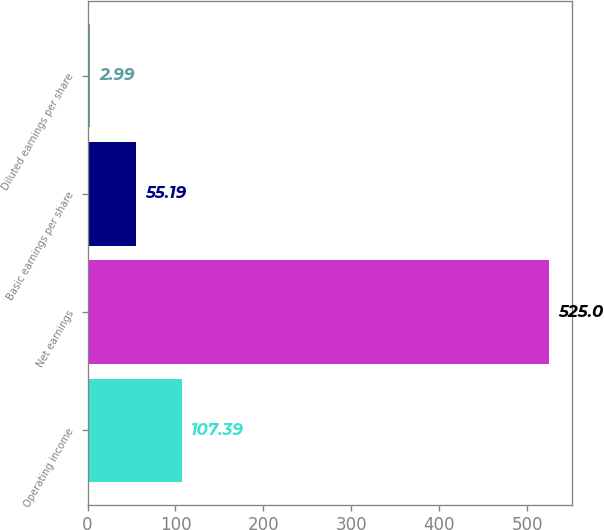<chart> <loc_0><loc_0><loc_500><loc_500><bar_chart><fcel>Operating income<fcel>Net earnings<fcel>Basic earnings per share<fcel>Diluted earnings per share<nl><fcel>107.39<fcel>525<fcel>55.19<fcel>2.99<nl></chart> 